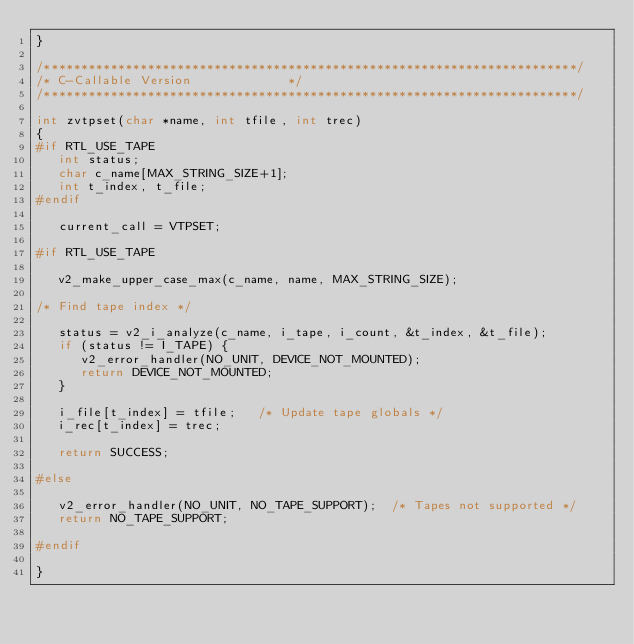Convert code to text. <code><loc_0><loc_0><loc_500><loc_500><_C_>}

/************************************************************************/
/* C-Callable Version							*/
/************************************************************************/

int zvtpset(char *name, int tfile, int trec)
{
#if RTL_USE_TAPE
   int status;
   char c_name[MAX_STRING_SIZE+1];
   int t_index, t_file;
#endif

   current_call = VTPSET;

#if RTL_USE_TAPE

   v2_make_upper_case_max(c_name, name, MAX_STRING_SIZE);

/* Find tape index */

   status = v2_i_analyze(c_name, i_tape, i_count, &t_index, &t_file);
   if (status != I_TAPE) {
      v2_error_handler(NO_UNIT, DEVICE_NOT_MOUNTED);
      return DEVICE_NOT_MOUNTED;
   }

   i_file[t_index] = tfile;		/* Update tape globals */
   i_rec[t_index] = trec;

   return SUCCESS;

#else

   v2_error_handler(NO_UNIT, NO_TAPE_SUPPORT);	/* Tapes not supported */
   return NO_TAPE_SUPPORT;

#endif

}
</code> 